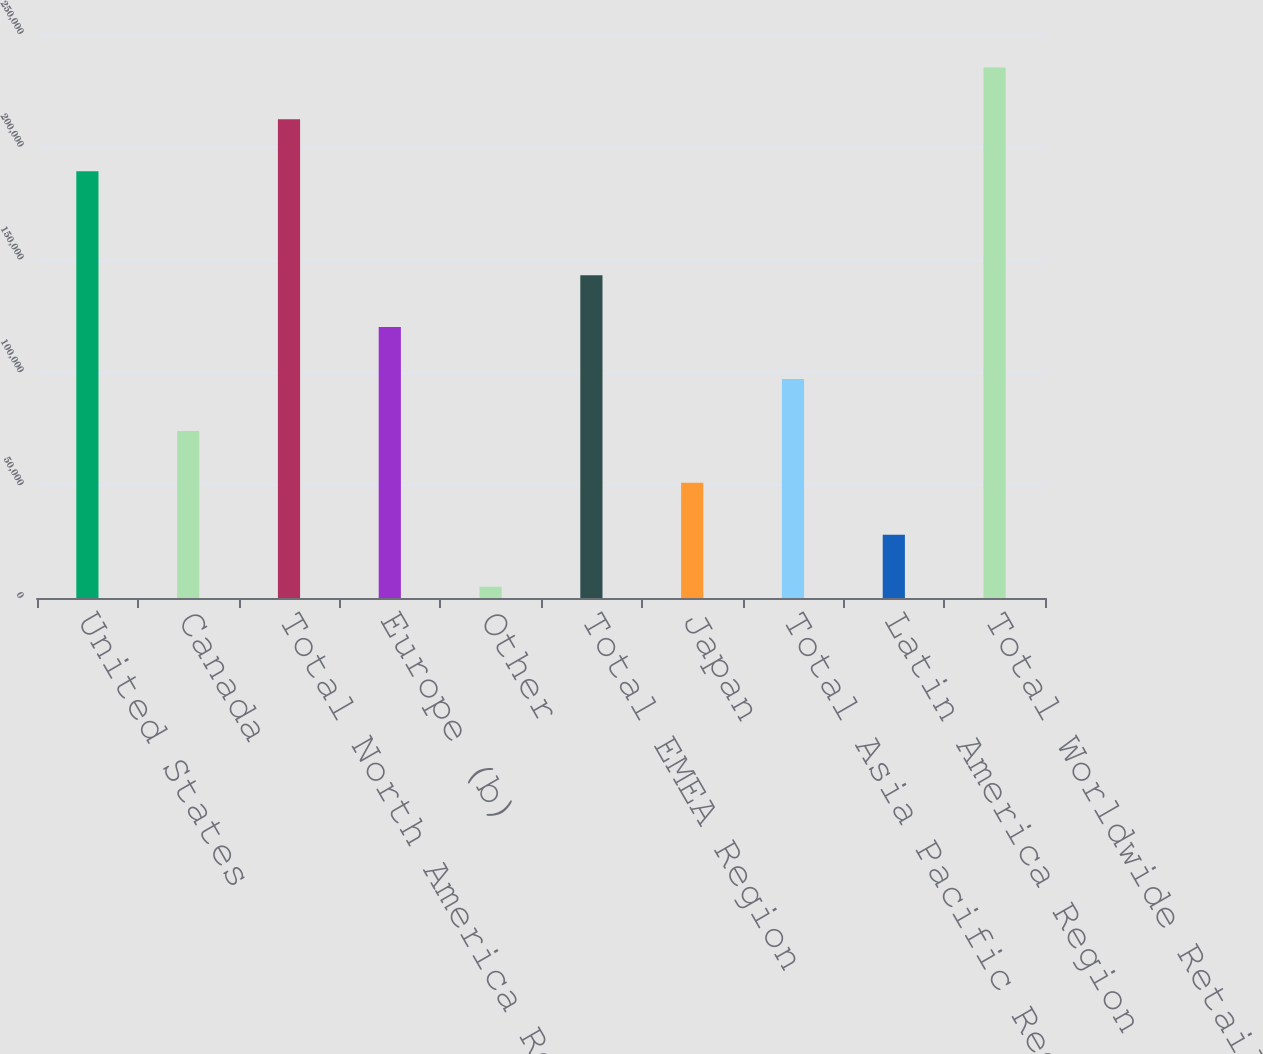Convert chart to OTSL. <chart><loc_0><loc_0><loc_500><loc_500><bar_chart><fcel>United States<fcel>Canada<fcel>Total North America Region<fcel>Europe (b)<fcel>Other<fcel>Total EMEA Region<fcel>Japan<fcel>Total Asia Pacific Region<fcel>Latin America Region<fcel>Total Worldwide Retail Sales<nl><fcel>189152<fcel>74060.6<fcel>212170<fcel>120097<fcel>5006<fcel>143115<fcel>51042.4<fcel>97078.8<fcel>28024.2<fcel>235188<nl></chart> 